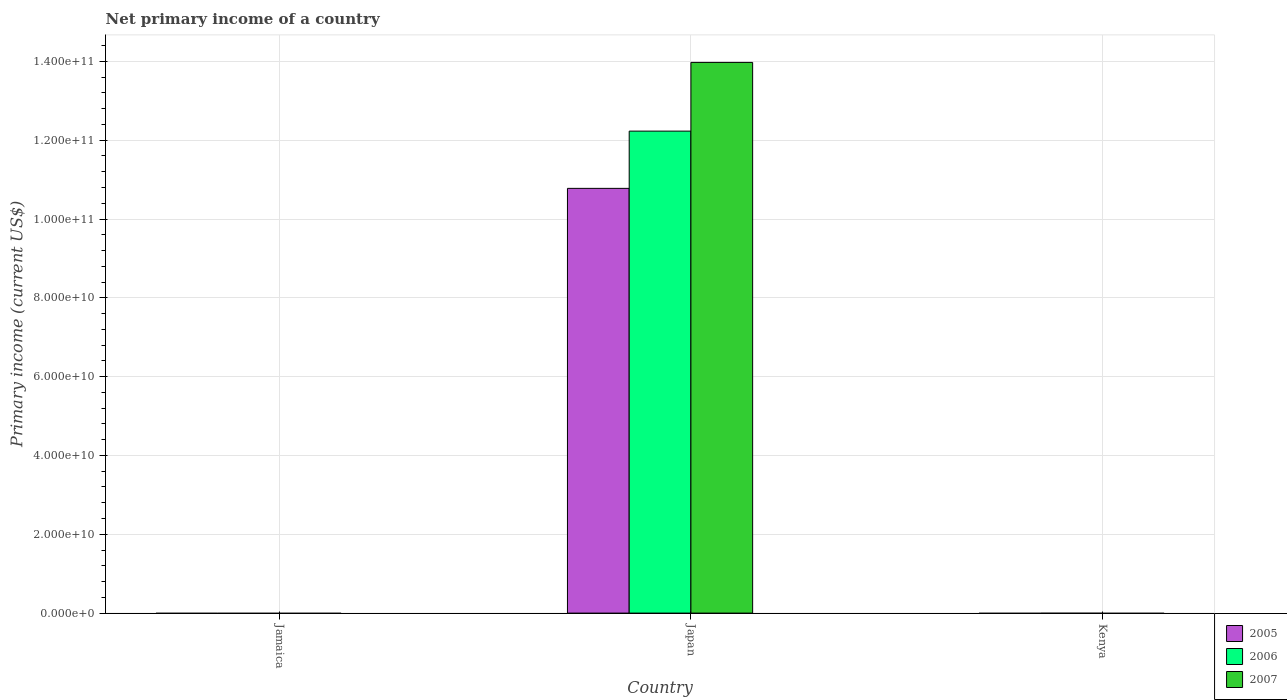How many different coloured bars are there?
Make the answer very short. 3. Are the number of bars on each tick of the X-axis equal?
Your response must be concise. No. How many bars are there on the 2nd tick from the right?
Provide a succinct answer. 3. What is the label of the 3rd group of bars from the left?
Provide a short and direct response. Kenya. In how many cases, is the number of bars for a given country not equal to the number of legend labels?
Keep it short and to the point. 2. Across all countries, what is the maximum primary income in 2007?
Provide a succinct answer. 1.40e+11. What is the total primary income in 2007 in the graph?
Provide a succinct answer. 1.40e+11. What is the difference between the primary income in 2005 in Japan and the primary income in 2007 in Kenya?
Offer a terse response. 1.08e+11. What is the average primary income in 2005 per country?
Your answer should be compact. 3.59e+1. What is the difference between the primary income of/in 2006 and primary income of/in 2007 in Japan?
Ensure brevity in your answer.  -1.74e+1. In how many countries, is the primary income in 2007 greater than 124000000000 US$?
Give a very brief answer. 1. What is the difference between the highest and the lowest primary income in 2005?
Ensure brevity in your answer.  1.08e+11. In how many countries, is the primary income in 2005 greater than the average primary income in 2005 taken over all countries?
Keep it short and to the point. 1. Is it the case that in every country, the sum of the primary income in 2007 and primary income in 2005 is greater than the primary income in 2006?
Provide a short and direct response. No. What is the difference between two consecutive major ticks on the Y-axis?
Your response must be concise. 2.00e+1. Does the graph contain any zero values?
Provide a succinct answer. Yes. Does the graph contain grids?
Keep it short and to the point. Yes. How are the legend labels stacked?
Provide a succinct answer. Vertical. What is the title of the graph?
Keep it short and to the point. Net primary income of a country. Does "1996" appear as one of the legend labels in the graph?
Keep it short and to the point. No. What is the label or title of the X-axis?
Make the answer very short. Country. What is the label or title of the Y-axis?
Provide a succinct answer. Primary income (current US$). What is the Primary income (current US$) of 2006 in Jamaica?
Ensure brevity in your answer.  0. What is the Primary income (current US$) in 2007 in Jamaica?
Provide a succinct answer. 0. What is the Primary income (current US$) of 2005 in Japan?
Your response must be concise. 1.08e+11. What is the Primary income (current US$) in 2006 in Japan?
Give a very brief answer. 1.22e+11. What is the Primary income (current US$) in 2007 in Japan?
Provide a succinct answer. 1.40e+11. What is the Primary income (current US$) in 2005 in Kenya?
Give a very brief answer. 0. What is the Primary income (current US$) in 2006 in Kenya?
Your answer should be compact. 0. Across all countries, what is the maximum Primary income (current US$) in 2005?
Keep it short and to the point. 1.08e+11. Across all countries, what is the maximum Primary income (current US$) in 2006?
Your answer should be compact. 1.22e+11. Across all countries, what is the maximum Primary income (current US$) in 2007?
Give a very brief answer. 1.40e+11. What is the total Primary income (current US$) of 2005 in the graph?
Provide a succinct answer. 1.08e+11. What is the total Primary income (current US$) of 2006 in the graph?
Offer a very short reply. 1.22e+11. What is the total Primary income (current US$) in 2007 in the graph?
Make the answer very short. 1.40e+11. What is the average Primary income (current US$) in 2005 per country?
Provide a succinct answer. 3.59e+1. What is the average Primary income (current US$) in 2006 per country?
Your answer should be compact. 4.08e+1. What is the average Primary income (current US$) in 2007 per country?
Offer a terse response. 4.66e+1. What is the difference between the Primary income (current US$) in 2005 and Primary income (current US$) in 2006 in Japan?
Your answer should be compact. -1.45e+1. What is the difference between the Primary income (current US$) of 2005 and Primary income (current US$) of 2007 in Japan?
Your response must be concise. -3.20e+1. What is the difference between the Primary income (current US$) in 2006 and Primary income (current US$) in 2007 in Japan?
Your answer should be very brief. -1.74e+1. What is the difference between the highest and the lowest Primary income (current US$) of 2005?
Offer a very short reply. 1.08e+11. What is the difference between the highest and the lowest Primary income (current US$) of 2006?
Your response must be concise. 1.22e+11. What is the difference between the highest and the lowest Primary income (current US$) in 2007?
Provide a short and direct response. 1.40e+11. 